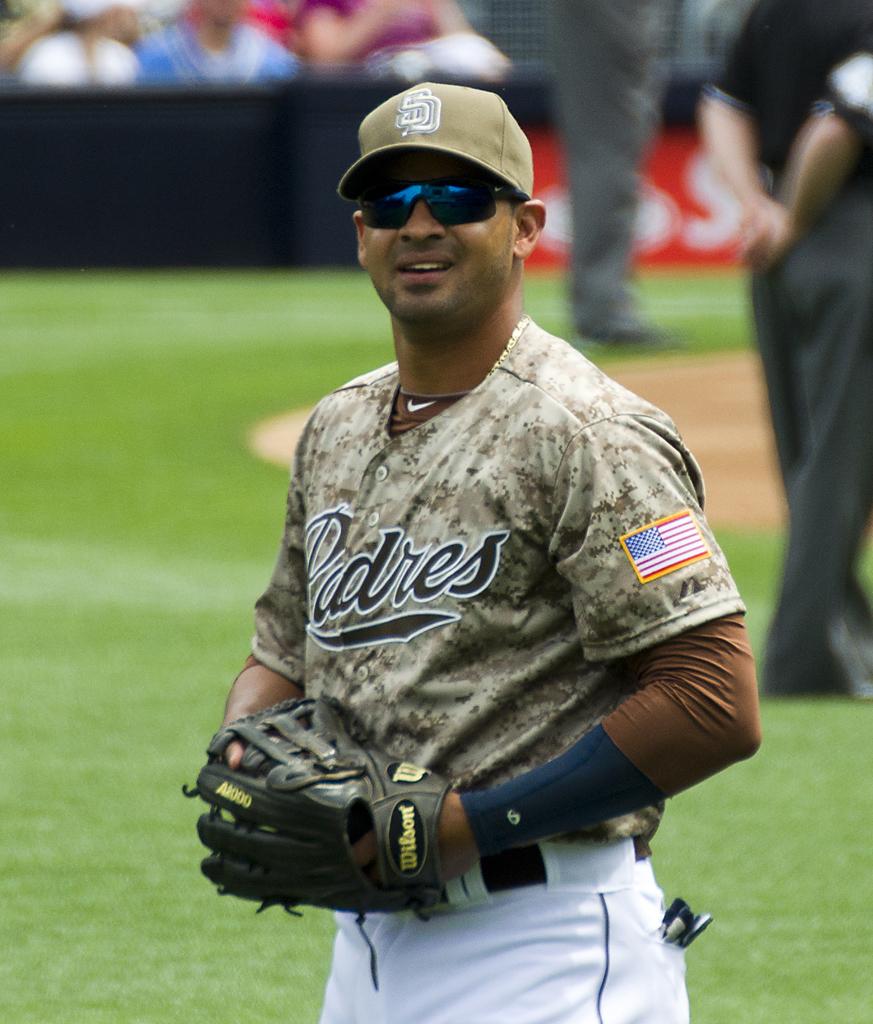What team is he playing for?
Offer a terse response. Padres. 